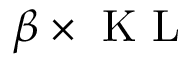Convert formula to latex. <formula><loc_0><loc_0><loc_500><loc_500>\beta \times K L</formula> 